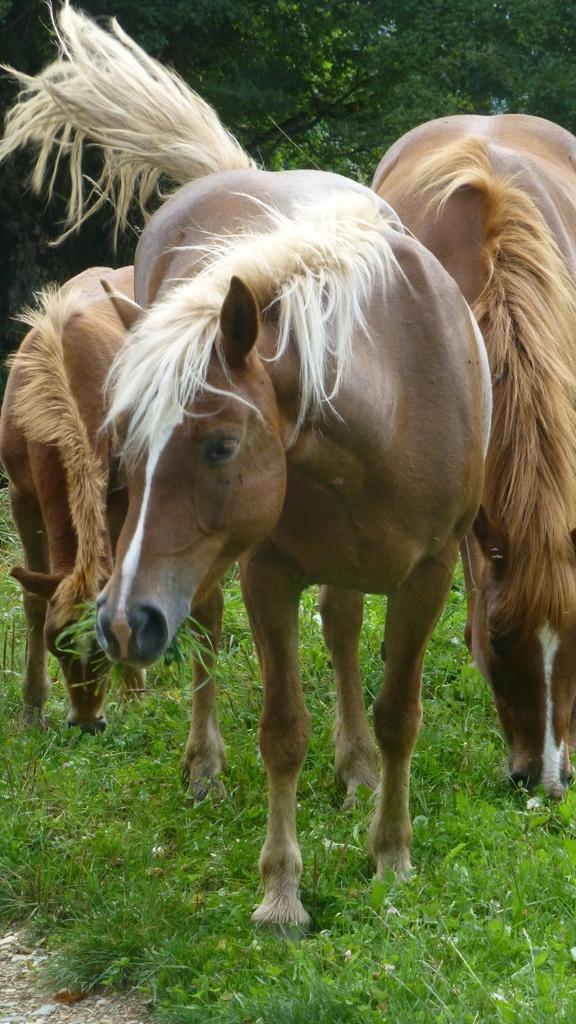Could you give a brief overview of what you see in this image? In this picture we can see white color hairs on this horse. On the right we can see another brown color horse who is eating grass. On the left we can see a small horse who is also eating the grass. On the background we can see many trees. 